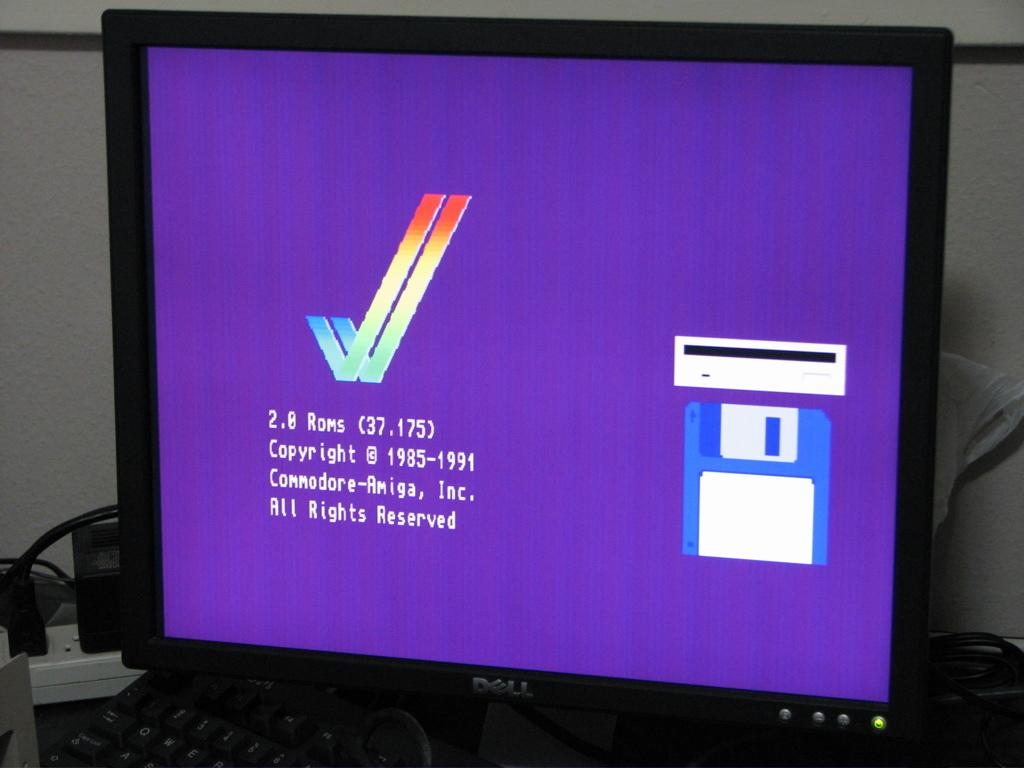<image>
Relay a brief, clear account of the picture shown. A Dell computer monitor with some copyright infor on it. 